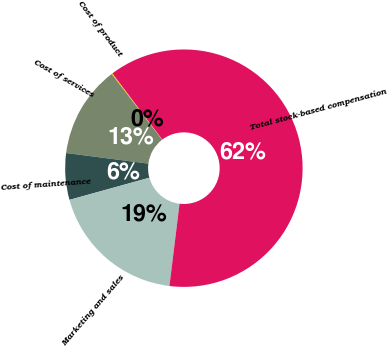<chart> <loc_0><loc_0><loc_500><loc_500><pie_chart><fcel>Cost of product<fcel>Cost of services<fcel>Cost of maintenance<fcel>Marketing and sales<fcel>Total stock-based compensation<nl><fcel>0.13%<fcel>12.55%<fcel>6.34%<fcel>18.76%<fcel>62.22%<nl></chart> 